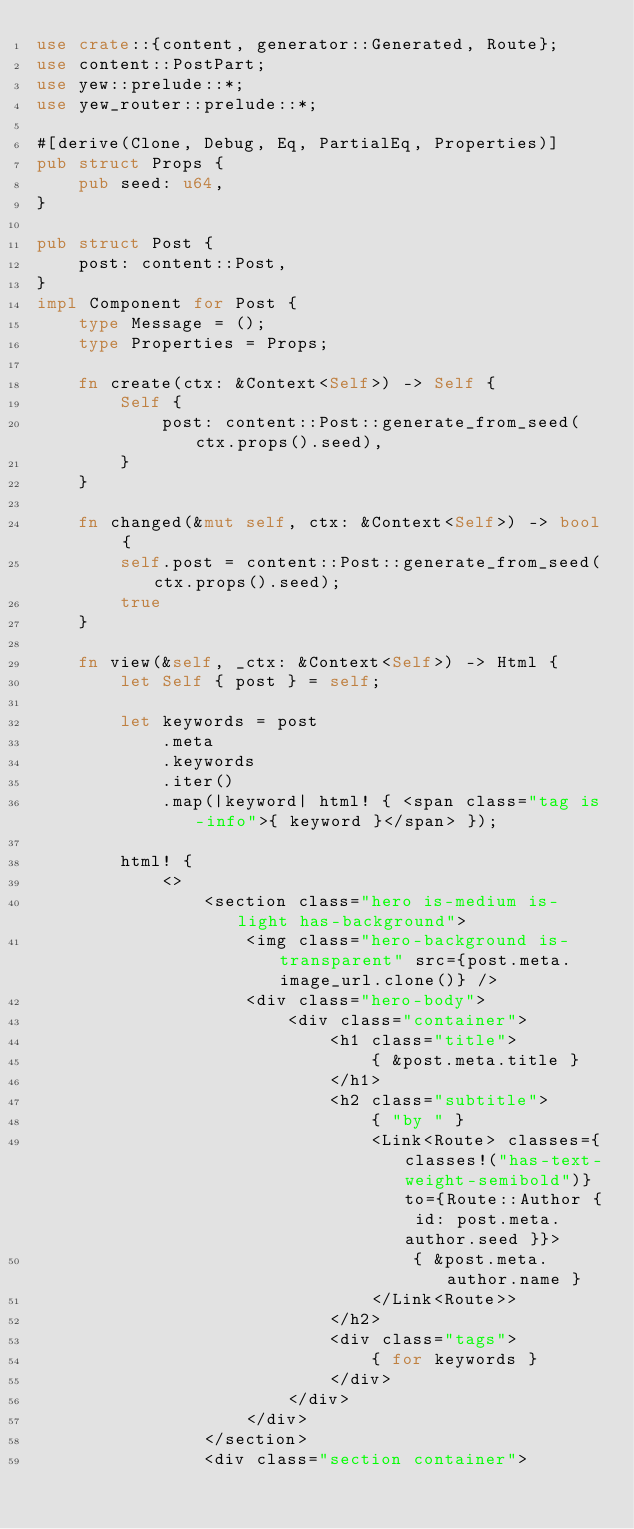<code> <loc_0><loc_0><loc_500><loc_500><_Rust_>use crate::{content, generator::Generated, Route};
use content::PostPart;
use yew::prelude::*;
use yew_router::prelude::*;

#[derive(Clone, Debug, Eq, PartialEq, Properties)]
pub struct Props {
    pub seed: u64,
}

pub struct Post {
    post: content::Post,
}
impl Component for Post {
    type Message = ();
    type Properties = Props;

    fn create(ctx: &Context<Self>) -> Self {
        Self {
            post: content::Post::generate_from_seed(ctx.props().seed),
        }
    }

    fn changed(&mut self, ctx: &Context<Self>) -> bool {
        self.post = content::Post::generate_from_seed(ctx.props().seed);
        true
    }

    fn view(&self, _ctx: &Context<Self>) -> Html {
        let Self { post } = self;

        let keywords = post
            .meta
            .keywords
            .iter()
            .map(|keyword| html! { <span class="tag is-info">{ keyword }</span> });

        html! {
            <>
                <section class="hero is-medium is-light has-background">
                    <img class="hero-background is-transparent" src={post.meta.image_url.clone()} />
                    <div class="hero-body">
                        <div class="container">
                            <h1 class="title">
                                { &post.meta.title }
                            </h1>
                            <h2 class="subtitle">
                                { "by " }
                                <Link<Route> classes={classes!("has-text-weight-semibold")} to={Route::Author { id: post.meta.author.seed }}>
                                    { &post.meta.author.name }
                                </Link<Route>>
                            </h2>
                            <div class="tags">
                                { for keywords }
                            </div>
                        </div>
                    </div>
                </section>
                <div class="section container"></code> 